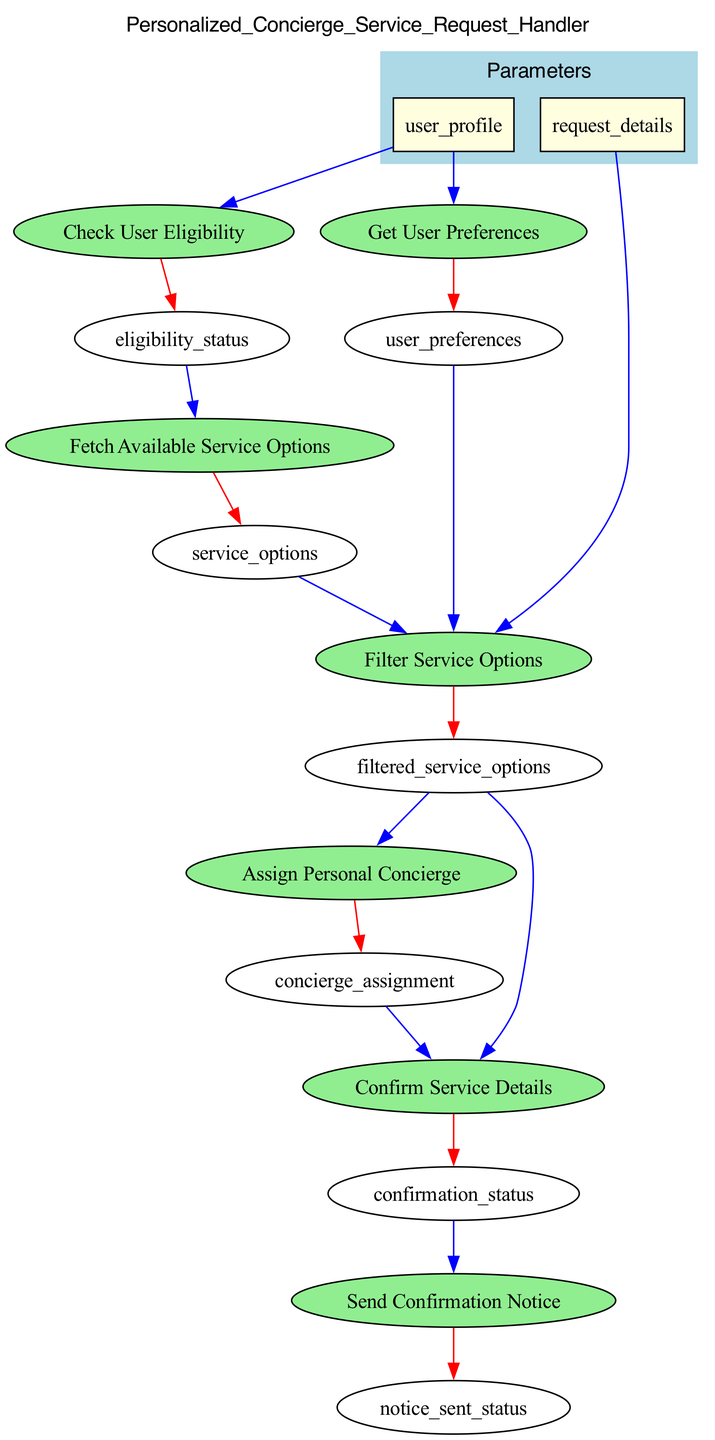What is the first step in the flowchart? The first step in the flowchart is "Check User Eligibility". This is shown at the top of the flowchart, indicating it is the starting point of the process.
Answer: Check User Eligibility How many parameters does the function have? The function has two parameters, which are listed under the "Parameters" cluster in the flowchart. These parameters are 'user_profile' and 'request_details'.
Answer: 2 What is the output of the 'Confirm Service Details' element? The output of the 'Confirm Service Details' element is "confirmation_status". This is indicated by the edge leading from 'Confirm Service Details' to 'confirmation_status' in the flowchart.
Answer: confirmation_status Which element receives input from 'user_preferences'? The element that receives input from 'user_preferences' is 'Filter Service Options'. This is represented by the connection (edge) from 'user_preferences' to 'Filter Service Options' in the diagram.
Answer: Filter Service Options What color are the nodes representing the main elements of the process? The nodes representing the main elements of the process are colored light green, as specified in the diagram settings for their style and appearance.
Answer: Light green Which two elements provide input to 'Assign Personal Concierge'? The two elements providing input to 'Assign Personal Concierge' are 'filtered_service_options' and 'filtered_service_options'. The flowchart shows both these elements connecting to 'Assign Personal Concierge' for its input.
Answer: filtered_service_options and user_preferences What happens after 'Send Confirmation Notice'? After 'Send Confirmation Notice', there is no further element, which indicates that this is the last step in the process. The flowchart terminates there following this action.
Answer: The process ends How many total elements are in the flowchart? The flowchart contains seven distinct elements, which are each represented by a unique node in the diagram.
Answer: 7 What is the relationship between 'Fetch Available Service Options' and 'Check User Eligibility'? The relationship is sequential; 'Fetch Available Service Options' receives its input from the output of 'Check User Eligibility', meaning it occurs after 'Check User Eligibility' in the flow of the process.
Answer: Sequential 